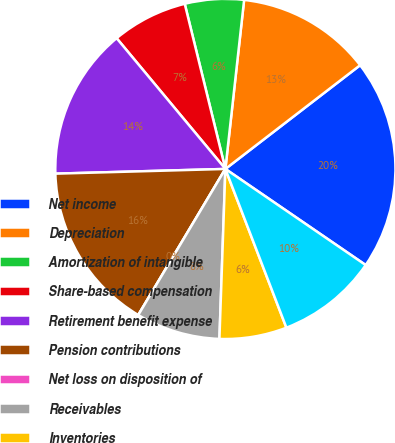<chart> <loc_0><loc_0><loc_500><loc_500><pie_chart><fcel>Net income<fcel>Depreciation<fcel>Amortization of intangible<fcel>Share-based compensation<fcel>Retirement benefit expense<fcel>Pension contributions<fcel>Net loss on disposition of<fcel>Receivables<fcel>Inventories<fcel>Accounts payable<nl><fcel>20.0%<fcel>12.8%<fcel>5.6%<fcel>7.2%<fcel>14.4%<fcel>16.0%<fcel>0.0%<fcel>8.0%<fcel>6.4%<fcel>9.6%<nl></chart> 